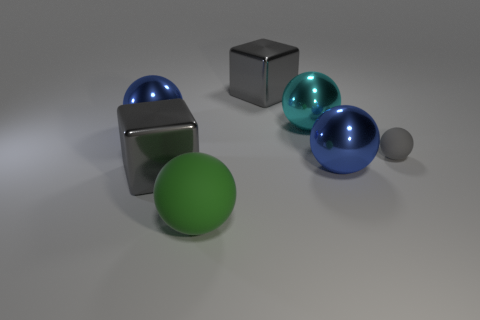Subtract 1 balls. How many balls are left? 4 Subtract all cyan balls. How many balls are left? 4 Subtract all large cyan balls. How many balls are left? 4 Subtract all purple balls. Subtract all red blocks. How many balls are left? 5 Add 3 blue metal objects. How many objects exist? 10 Subtract all cubes. How many objects are left? 5 Add 3 gray matte things. How many gray matte things exist? 4 Subtract 1 cyan spheres. How many objects are left? 6 Subtract all cyan objects. Subtract all large purple shiny blocks. How many objects are left? 6 Add 3 large green matte balls. How many large green matte balls are left? 4 